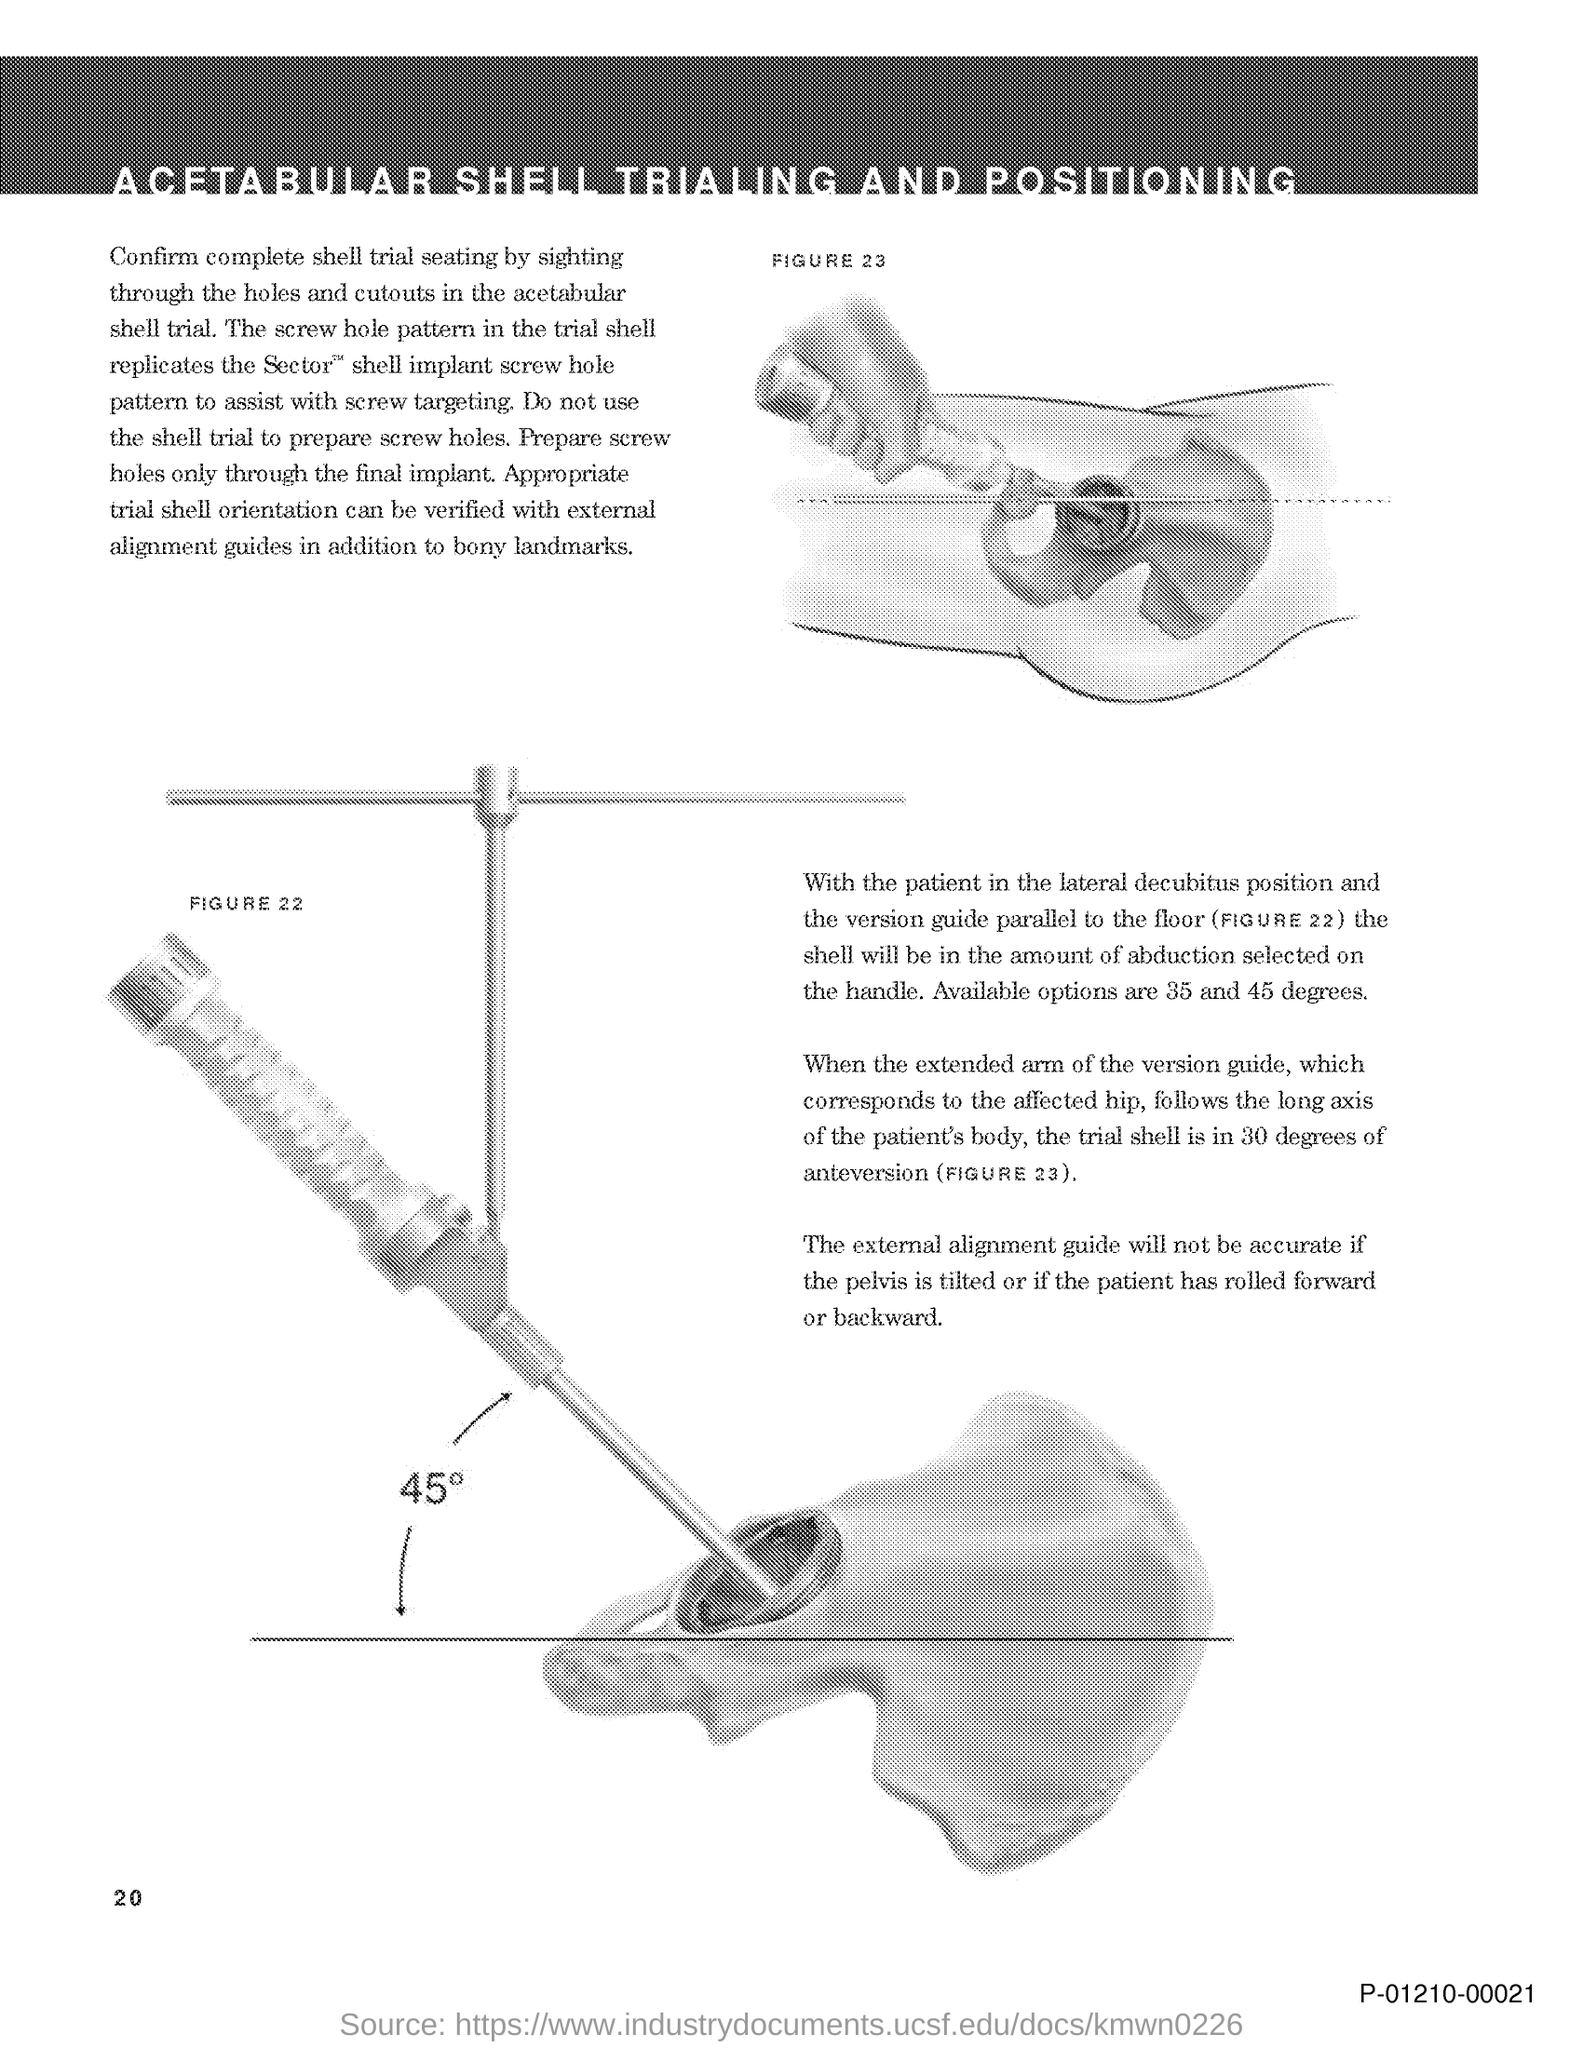Specify some key components in this picture. I will use the shell to place the patient in the lateral decubitus position and align the version guide parallel to the floor, ensuring that the shell is in the appropriate position for the amount of abduction selected. To ensure the appropriate trial shell orientation, it is recommended to use external alignment guides in addition to bony landmarks during the procedure. The screw hole pattern in the trial shell is designed to replicate the screw hole pattern of the Sector shell implant in order to assist with accurate screw targeting. There are two options available for selection: 35 and 45 degrees of abduction. 